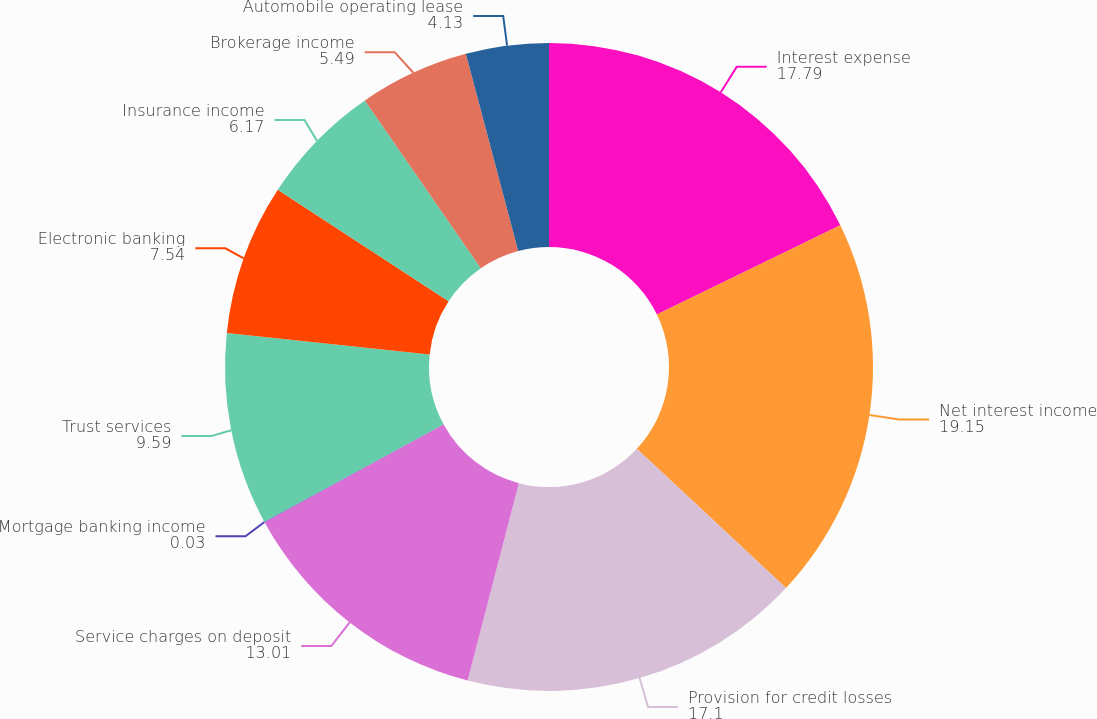Convert chart. <chart><loc_0><loc_0><loc_500><loc_500><pie_chart><fcel>Interest expense<fcel>Net interest income<fcel>Provision for credit losses<fcel>Service charges on deposit<fcel>Mortgage banking income<fcel>Trust services<fcel>Electronic banking<fcel>Insurance income<fcel>Brokerage income<fcel>Automobile operating lease<nl><fcel>17.79%<fcel>19.15%<fcel>17.1%<fcel>13.01%<fcel>0.03%<fcel>9.59%<fcel>7.54%<fcel>6.17%<fcel>5.49%<fcel>4.13%<nl></chart> 